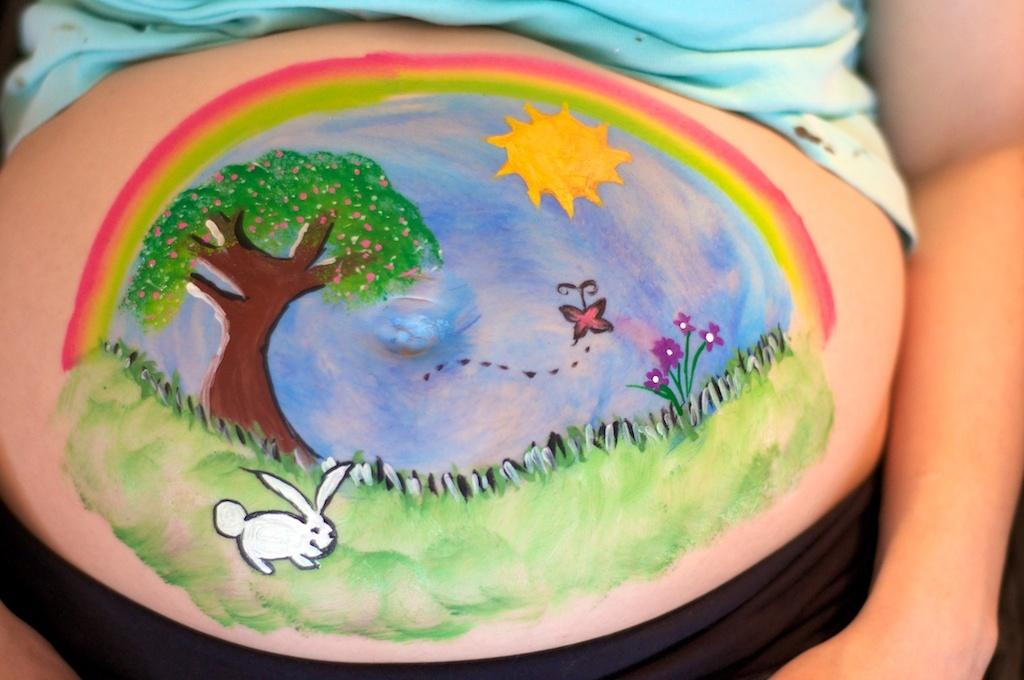What is the main subject of the drawing in the image? There is a person in the image. What type of natural environment is depicted in the drawing? The drawing includes grass, as it includes grass, sky, a plant, flowers, a tree, and the sun. Are there any animals present in the drawing? Yes, there is a butterfly and a rabbit in the drawing. What type of swing can be seen in the drawing? There is no swing present in the drawing; it only includes a person, a natural environment, and a few animals. What is the date on the calendar in the drawing? There is no calendar present in the drawing; it only includes a person, a natural environment, and a few animals. 